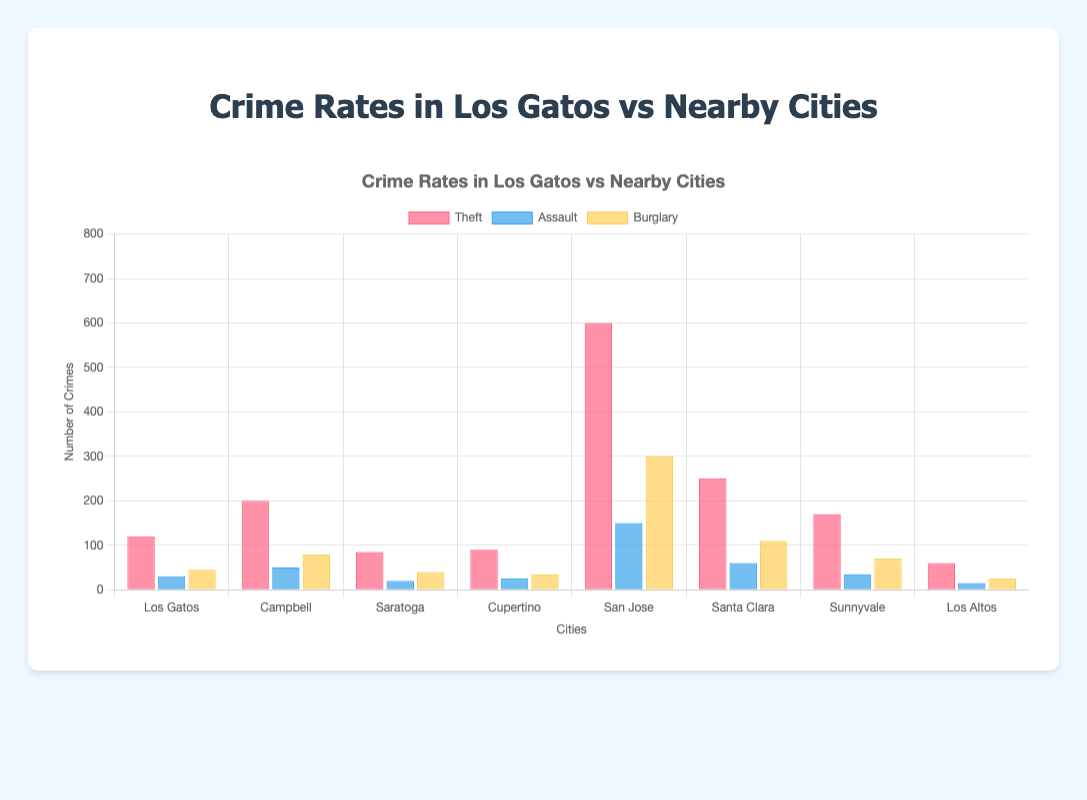What's the total number of theft incidents in all cities? Sum the number of theft incidents for all cities: Los Gatos (120) + Campbell (200) + Saratoga (85) + Cupertino (90) + San Jose (600) + Santa Clara (250) + Sunnyvale (170) + Los Altos (60). 120 + 200 + 85 + 90 + 600 + 250 + 170 + 60 = 1575.
Answer: 1575 Which city has the highest number of burglary incidents? Compare the burglary incidents across all cities: Los Gatos (45), Campbell (80), Saratoga (40), Cupertino (35), San Jose (300), Santa Clara (110), Sunnyvale (70), and Los Altos (25). San Jose has the highest number with 300 incidents.
Answer: San Jose Between Los Gatos and Santa Clara, which city has a higher overall crime rate (i.e., the sum of all types of crimes)? Add the total incidents of each crime type for Los Gatos and Santa Clara: Los Gatos (120 Theft + 30 Assault + 45 Burglary = 195 total), Santa Clara (250 Theft + 60 Assault + 110 Burglary = 420 total). Santa Clara has a higher overall crime rate.
Answer: Santa Clara What color represents the burglary incidents in the bar chart? Based on the visual attributes, burglary incidents are shown in bars colored in yellow.
Answer: Yellow Which type of crime is most prevalent in Cupertino? Compare the values for each crime type in Cupertino: Theft (90), Assault (25), Burglary (35). The highest number is Theft with 90 incidents.
Answer: Theft What is the difference in the number of assault incidents between San Jose and Sunnyvale? Subtract the number of assault incidents in Sunnyvale (35) from San Jose (150). 150 - 35 = 115.
Answer: 115 How does the number of theft incidents in Los Gatos compare to that in Sunnyvale? Compare the numbers: Los Gatos (120) and Sunnyvale (170). Sunnyvale has 50 more theft incidents than Los Gatos.
Answer: Sunnyvale has more theft incidents In which city does theft represent the smallest proportion of total crimes? Calculate the proportion of theft for each city and compare: Los Gatos (120 of 195), Campbell (200 of 330), Saratoga (85 of 145), Cupertino (90 of 150), San Jose (600 of 1050), Santa Clara (250 of 420), Sunnyvale (170 of 275), Los Altos (60 of 100). Cupertino has the smallest theft proportion (90/150 = 0.6).
Answer: Cupertino What is the average number of assault incidents across all cities? Sum the total number of assault incidents (30 + 50 + 20 + 25 + 150 + 60 + 35 + 15 = 385) and divide by the number of cities (8). 385/8 = 48.125.
Answer: 48.125 